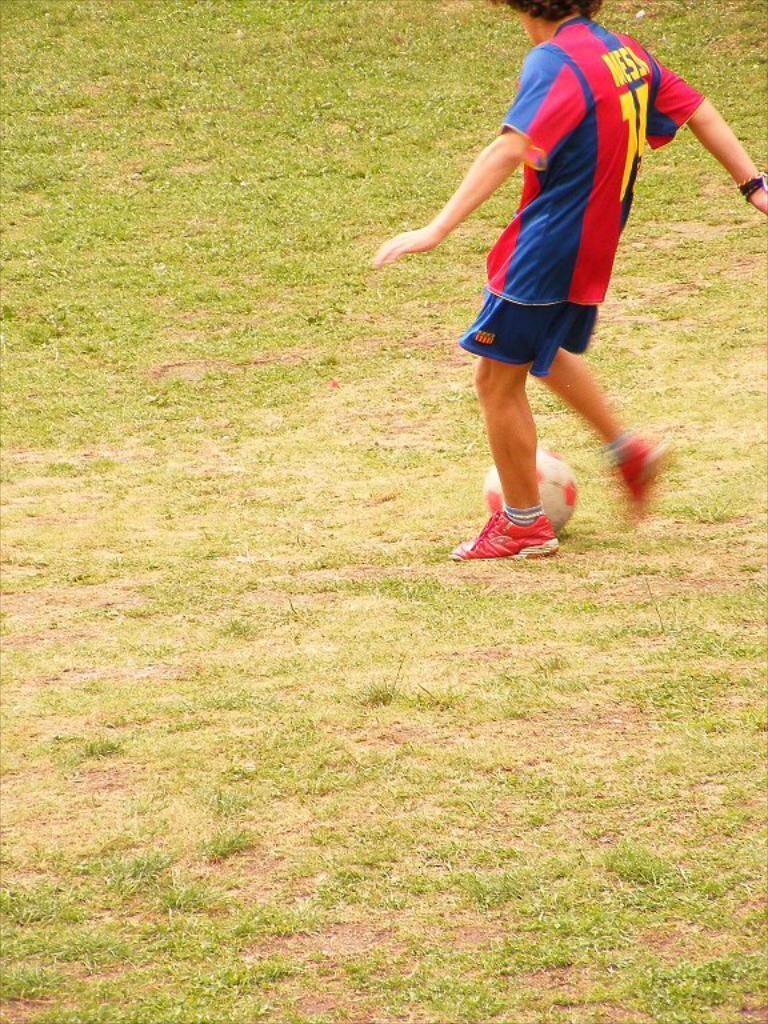Please provide a concise description of this image. In the picture I can see a person is standing on the ground. I can also see the grass and a ball on the ground. 